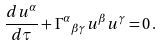Convert formula to latex. <formula><loc_0><loc_0><loc_500><loc_500>\frac { d u ^ { \alpha } } { d \tau } + { \Gamma ^ { \alpha } } _ { \beta \gamma } u ^ { \beta } u ^ { \gamma } = 0 \, .</formula> 